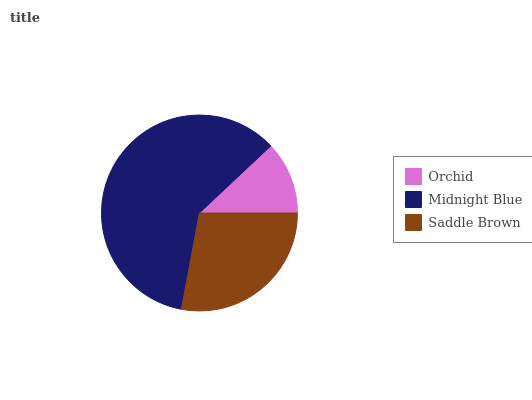Is Orchid the minimum?
Answer yes or no. Yes. Is Midnight Blue the maximum?
Answer yes or no. Yes. Is Saddle Brown the minimum?
Answer yes or no. No. Is Saddle Brown the maximum?
Answer yes or no. No. Is Midnight Blue greater than Saddle Brown?
Answer yes or no. Yes. Is Saddle Brown less than Midnight Blue?
Answer yes or no. Yes. Is Saddle Brown greater than Midnight Blue?
Answer yes or no. No. Is Midnight Blue less than Saddle Brown?
Answer yes or no. No. Is Saddle Brown the high median?
Answer yes or no. Yes. Is Saddle Brown the low median?
Answer yes or no. Yes. Is Orchid the high median?
Answer yes or no. No. Is Orchid the low median?
Answer yes or no. No. 